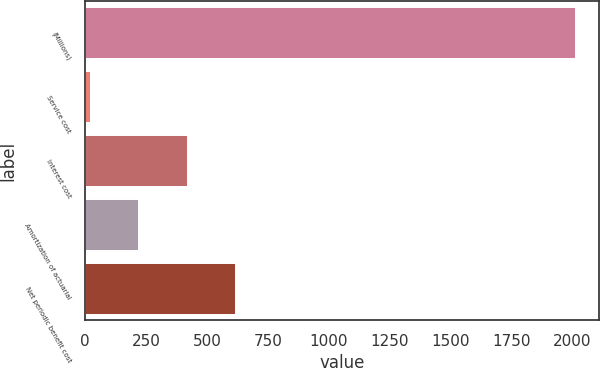Convert chart. <chart><loc_0><loc_0><loc_500><loc_500><bar_chart><fcel>(Millions)<fcel>Service cost<fcel>Interest cost<fcel>Amortization of actuarial<fcel>Net periodic benefit cost<nl><fcel>2011<fcel>19<fcel>417.4<fcel>218.2<fcel>616.6<nl></chart> 